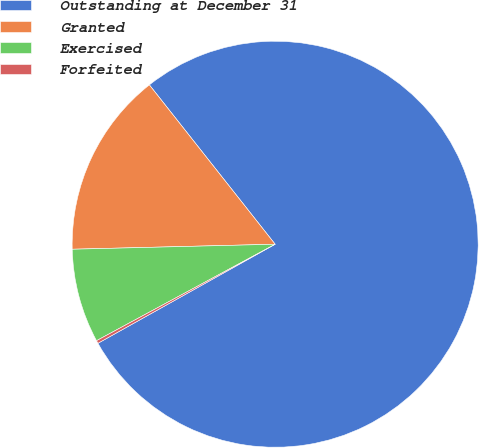Convert chart. <chart><loc_0><loc_0><loc_500><loc_500><pie_chart><fcel>Outstanding at December 31<fcel>Granted<fcel>Exercised<fcel>Forfeited<nl><fcel>77.53%<fcel>14.76%<fcel>7.49%<fcel>0.23%<nl></chart> 